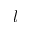Convert formula to latex. <formula><loc_0><loc_0><loc_500><loc_500>l</formula> 